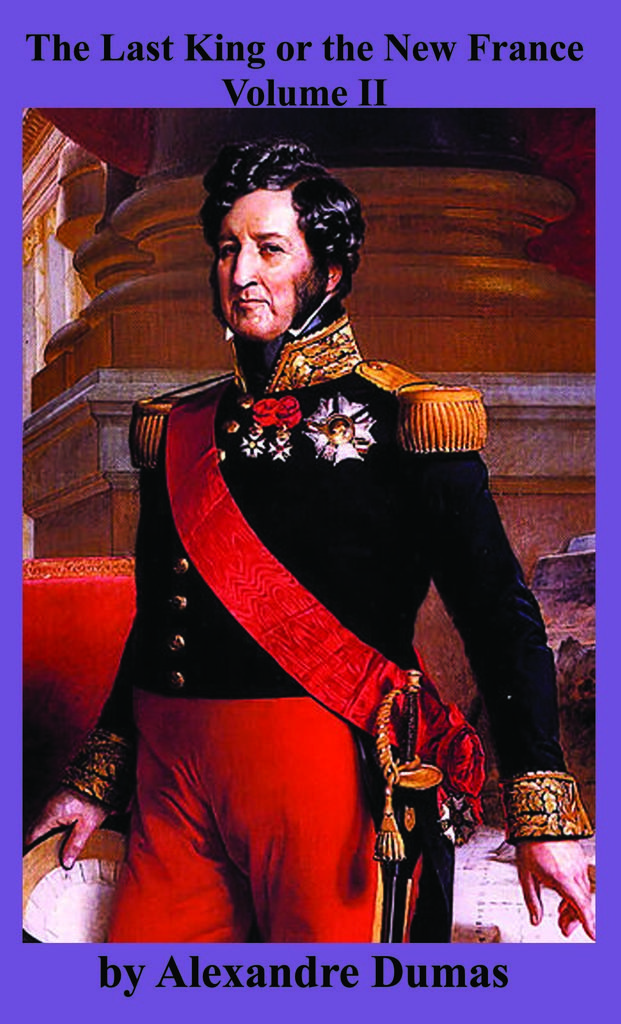Who is the author?
Give a very brief answer. Alexandre dumas. What country is this man from?
Give a very brief answer. France. 